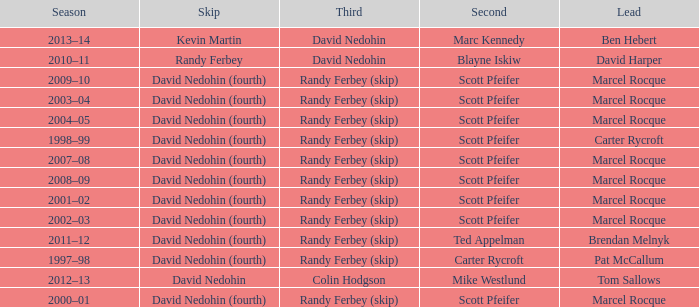Which Third has a Second of scott pfeifer? Randy Ferbey (skip), Randy Ferbey (skip), Randy Ferbey (skip), Randy Ferbey (skip), Randy Ferbey (skip), Randy Ferbey (skip), Randy Ferbey (skip), Randy Ferbey (skip), Randy Ferbey (skip). 